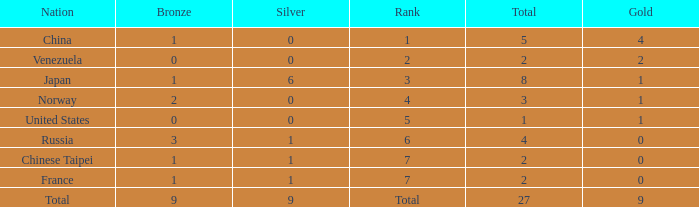What is the average Bronze for rank 3 and total is more than 8? None. 